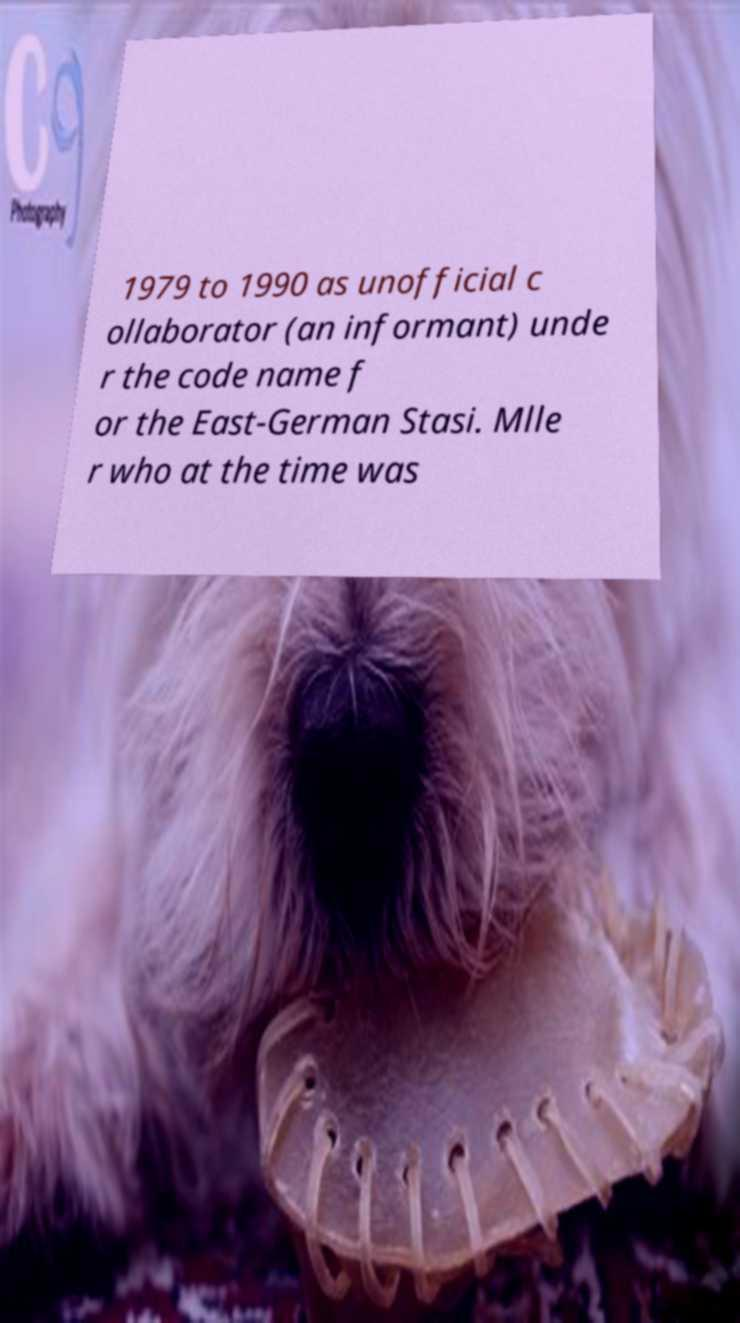Can you read and provide the text displayed in the image?This photo seems to have some interesting text. Can you extract and type it out for me? 1979 to 1990 as unofficial c ollaborator (an informant) unde r the code name f or the East-German Stasi. Mlle r who at the time was 